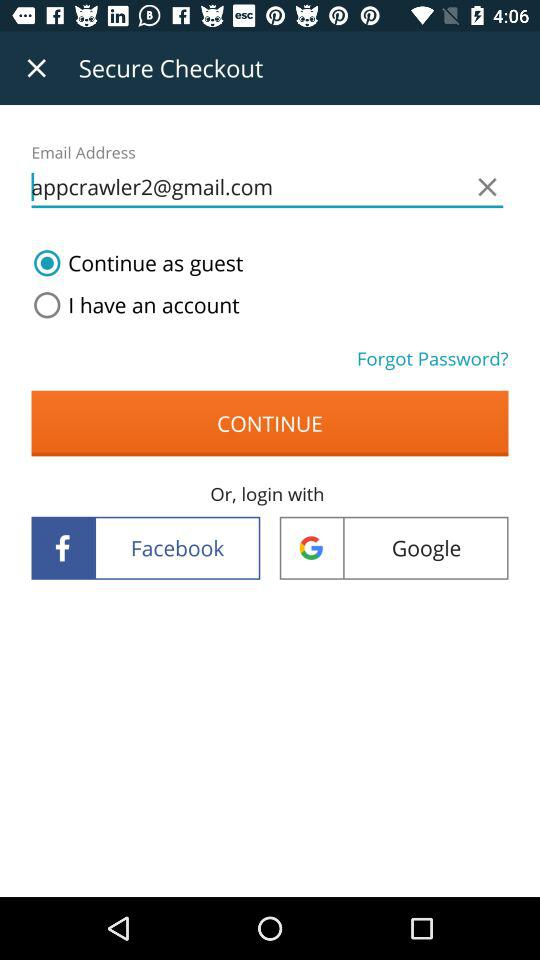What is an email address? The email address is appcrawler2@gmail.com. 